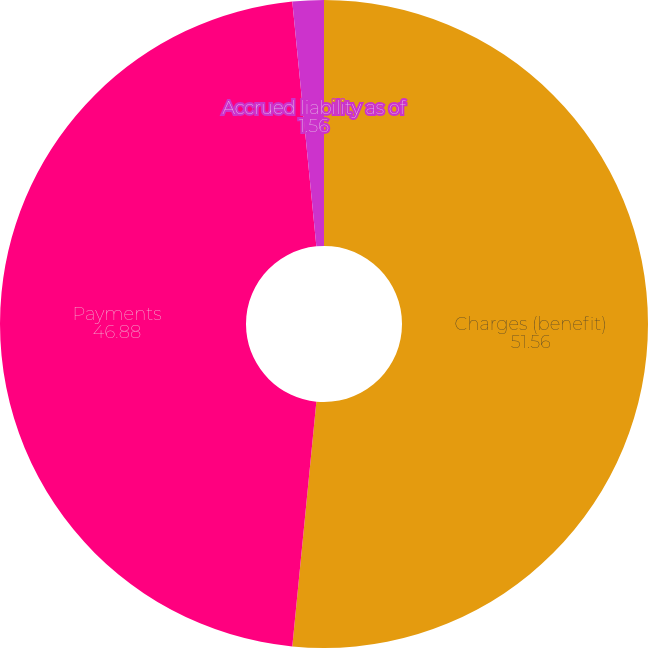Convert chart. <chart><loc_0><loc_0><loc_500><loc_500><pie_chart><fcel>Charges (benefit)<fcel>Payments<fcel>Accrued liability as of<nl><fcel>51.56%<fcel>46.88%<fcel>1.56%<nl></chart> 